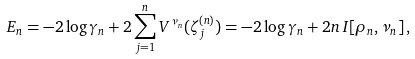<formula> <loc_0><loc_0><loc_500><loc_500>E _ { n } = - 2 \log \gamma _ { n } + 2 \sum _ { j = 1 } ^ { n } V ^ { \nu _ { n } } ( \zeta _ { j } ^ { ( n ) } ) = - 2 \log \gamma _ { n } + 2 n \, I [ \rho _ { n } , \nu _ { n } ] \, ,</formula> 